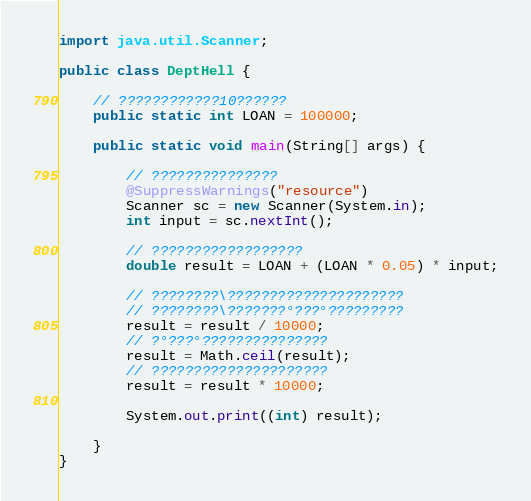Convert code to text. <code><loc_0><loc_0><loc_500><loc_500><_Java_>import java.util.Scanner;

public class DeptHell {

	// ????????????10??????
	public static int LOAN = 100000;

	public static void main(String[] args) {

		// ???????????????
		@SuppressWarnings("resource")
		Scanner sc = new Scanner(System.in);
		int input = sc.nextInt();

		// ??????????????????
		double result = LOAN + (LOAN * 0.05) * input;

		// ????????\?????????????????????
		// ????????\???????°???°?????????
		result = result / 10000;
		// ?°???°???????????????
		result = Math.ceil(result);
		// ?????????????????????
		result = result * 10000;

		System.out.print((int) result);

	}
}</code> 